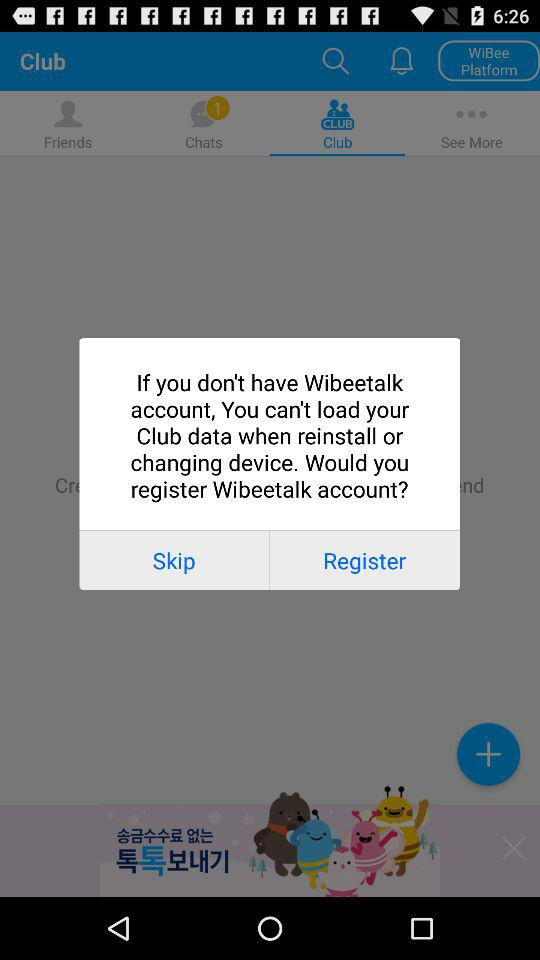How many terms of service items are there?
Answer the question using a single word or phrase. 3 